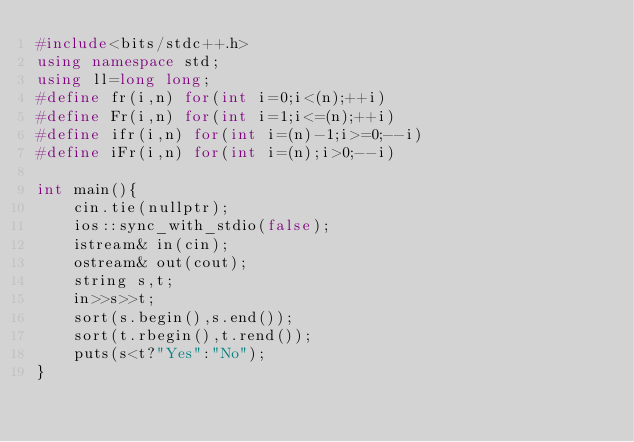<code> <loc_0><loc_0><loc_500><loc_500><_C++_>#include<bits/stdc++.h>
using namespace std;
using ll=long long;
#define fr(i,n) for(int i=0;i<(n);++i)
#define Fr(i,n) for(int i=1;i<=(n);++i)
#define ifr(i,n) for(int i=(n)-1;i>=0;--i)
#define iFr(i,n) for(int i=(n);i>0;--i)

int main(){
    cin.tie(nullptr);
    ios::sync_with_stdio(false);
    istream& in(cin);
    ostream& out(cout);
    string s,t;
    in>>s>>t;
    sort(s.begin(),s.end());
    sort(t.rbegin(),t.rend());
    puts(s<t?"Yes":"No");
}</code> 